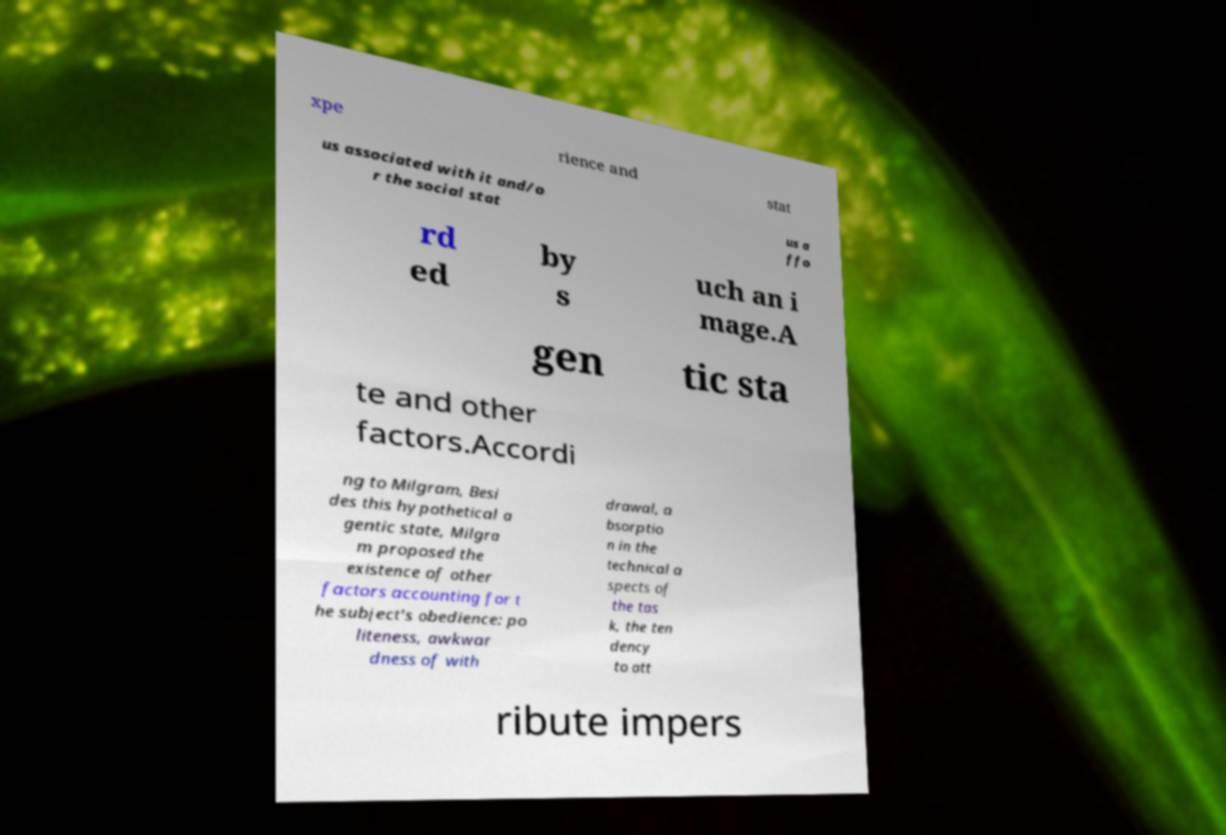Could you assist in decoding the text presented in this image and type it out clearly? xpe rience and stat us associated with it and/o r the social stat us a ffo rd ed by s uch an i mage.A gen tic sta te and other factors.Accordi ng to Milgram, Besi des this hypothetical a gentic state, Milgra m proposed the existence of other factors accounting for t he subject's obedience: po liteness, awkwar dness of with drawal, a bsorptio n in the technical a spects of the tas k, the ten dency to att ribute impers 